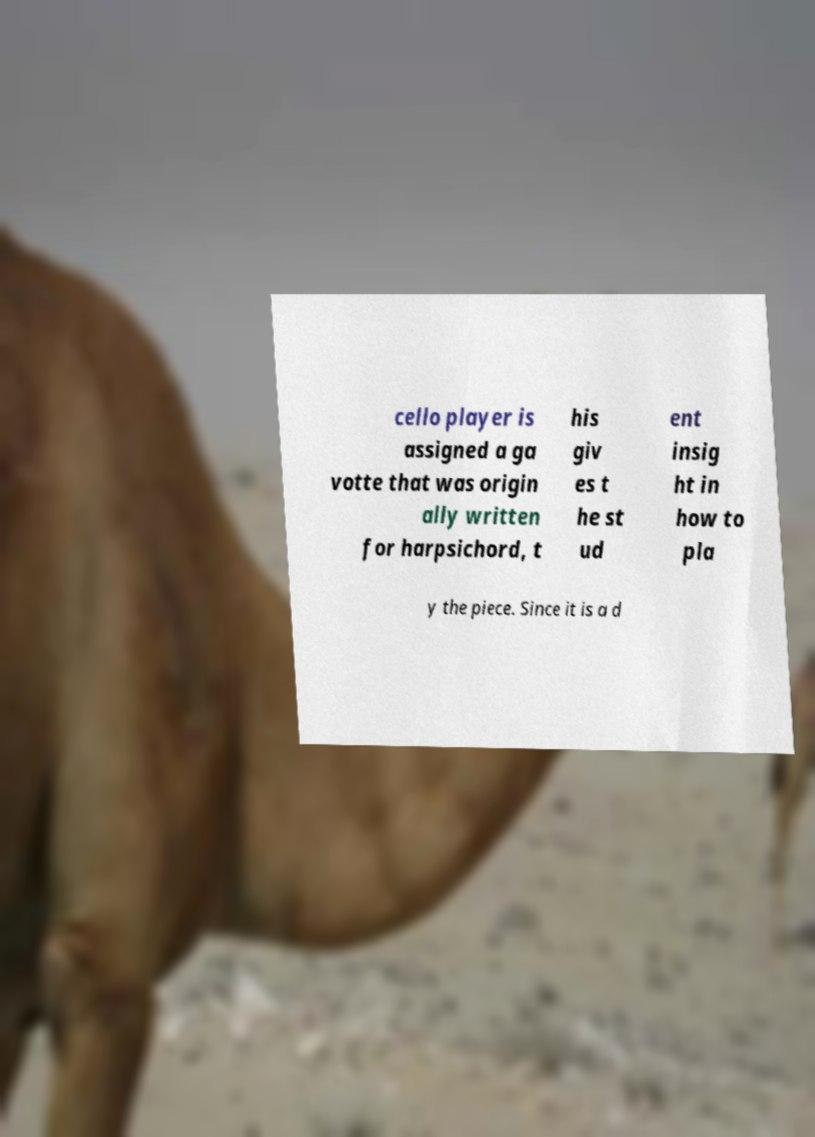For documentation purposes, I need the text within this image transcribed. Could you provide that? cello player is assigned a ga votte that was origin ally written for harpsichord, t his giv es t he st ud ent insig ht in how to pla y the piece. Since it is a d 